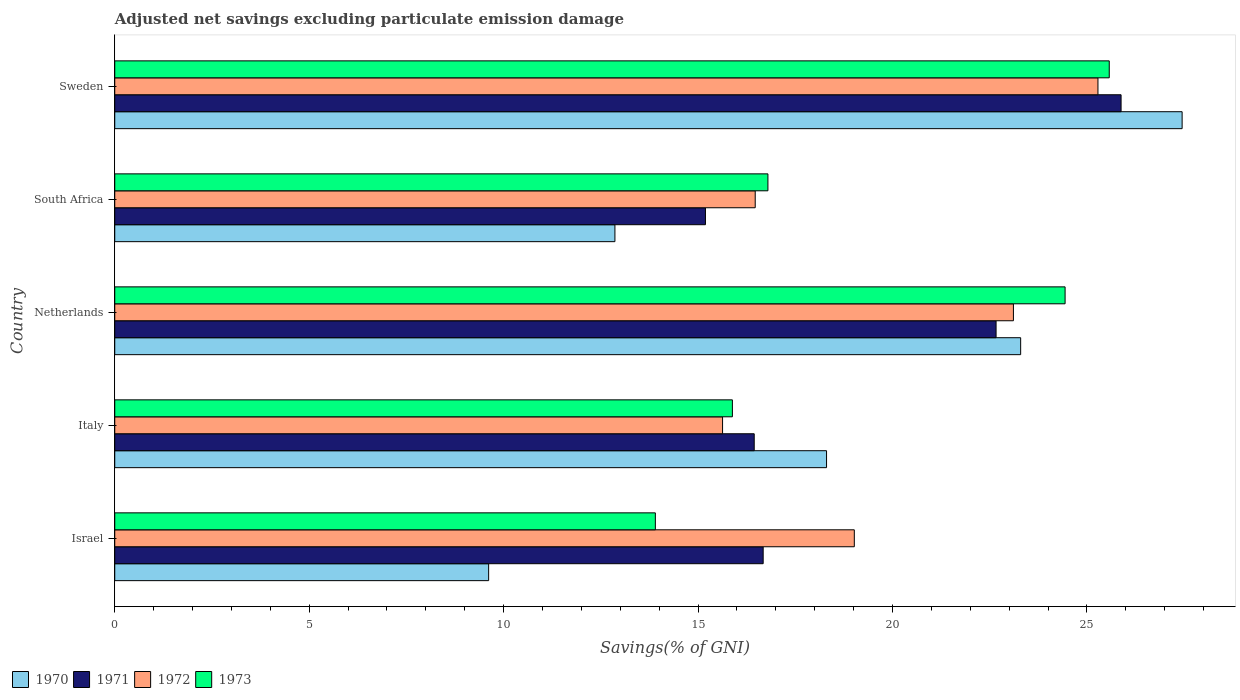How many different coloured bars are there?
Provide a short and direct response. 4. Are the number of bars on each tick of the Y-axis equal?
Give a very brief answer. Yes. What is the adjusted net savings in 1971 in Israel?
Offer a terse response. 16.67. Across all countries, what is the maximum adjusted net savings in 1971?
Your answer should be compact. 25.88. Across all countries, what is the minimum adjusted net savings in 1973?
Provide a short and direct response. 13.9. In which country was the adjusted net savings in 1972 maximum?
Provide a succinct answer. Sweden. In which country was the adjusted net savings in 1971 minimum?
Your answer should be very brief. South Africa. What is the total adjusted net savings in 1970 in the graph?
Offer a very short reply. 91.52. What is the difference between the adjusted net savings in 1972 in Italy and that in Netherlands?
Provide a short and direct response. -7.48. What is the difference between the adjusted net savings in 1972 in Italy and the adjusted net savings in 1973 in Israel?
Offer a terse response. 1.73. What is the average adjusted net savings in 1973 per country?
Your answer should be compact. 19.32. What is the difference between the adjusted net savings in 1970 and adjusted net savings in 1972 in Sweden?
Ensure brevity in your answer.  2.16. In how many countries, is the adjusted net savings in 1973 greater than 26 %?
Keep it short and to the point. 0. What is the ratio of the adjusted net savings in 1973 in Israel to that in Italy?
Ensure brevity in your answer.  0.88. Is the adjusted net savings in 1972 in South Africa less than that in Sweden?
Offer a terse response. Yes. What is the difference between the highest and the second highest adjusted net savings in 1971?
Offer a very short reply. 3.21. What is the difference between the highest and the lowest adjusted net savings in 1972?
Make the answer very short. 9.65. Is the sum of the adjusted net savings in 1972 in South Africa and Sweden greater than the maximum adjusted net savings in 1970 across all countries?
Keep it short and to the point. Yes. What does the 2nd bar from the top in Sweden represents?
Provide a short and direct response. 1972. Is it the case that in every country, the sum of the adjusted net savings in 1970 and adjusted net savings in 1973 is greater than the adjusted net savings in 1971?
Ensure brevity in your answer.  Yes. How many bars are there?
Offer a very short reply. 20. How many countries are there in the graph?
Keep it short and to the point. 5. What is the difference between two consecutive major ticks on the X-axis?
Offer a very short reply. 5. Does the graph contain any zero values?
Provide a short and direct response. No. Does the graph contain grids?
Provide a succinct answer. No. How many legend labels are there?
Provide a short and direct response. 4. How are the legend labels stacked?
Offer a very short reply. Horizontal. What is the title of the graph?
Offer a very short reply. Adjusted net savings excluding particulate emission damage. Does "2001" appear as one of the legend labels in the graph?
Provide a short and direct response. No. What is the label or title of the X-axis?
Your answer should be very brief. Savings(% of GNI). What is the label or title of the Y-axis?
Offer a very short reply. Country. What is the Savings(% of GNI) of 1970 in Israel?
Give a very brief answer. 9.61. What is the Savings(% of GNI) in 1971 in Israel?
Keep it short and to the point. 16.67. What is the Savings(% of GNI) in 1972 in Israel?
Offer a very short reply. 19.02. What is the Savings(% of GNI) in 1973 in Israel?
Offer a terse response. 13.9. What is the Savings(% of GNI) of 1970 in Italy?
Your response must be concise. 18.3. What is the Savings(% of GNI) in 1971 in Italy?
Your response must be concise. 16.44. What is the Savings(% of GNI) in 1972 in Italy?
Provide a short and direct response. 15.63. What is the Savings(% of GNI) in 1973 in Italy?
Offer a very short reply. 15.88. What is the Savings(% of GNI) in 1970 in Netherlands?
Offer a terse response. 23.3. What is the Savings(% of GNI) of 1971 in Netherlands?
Provide a succinct answer. 22.66. What is the Savings(% of GNI) of 1972 in Netherlands?
Provide a succinct answer. 23.11. What is the Savings(% of GNI) of 1973 in Netherlands?
Provide a short and direct response. 24.44. What is the Savings(% of GNI) in 1970 in South Africa?
Provide a succinct answer. 12.86. What is the Savings(% of GNI) of 1971 in South Africa?
Make the answer very short. 15.19. What is the Savings(% of GNI) in 1972 in South Africa?
Provide a short and direct response. 16.47. What is the Savings(% of GNI) of 1973 in South Africa?
Provide a succinct answer. 16.8. What is the Savings(% of GNI) of 1970 in Sweden?
Offer a very short reply. 27.45. What is the Savings(% of GNI) of 1971 in Sweden?
Provide a short and direct response. 25.88. What is the Savings(% of GNI) in 1972 in Sweden?
Your response must be concise. 25.28. What is the Savings(% of GNI) in 1973 in Sweden?
Offer a very short reply. 25.57. Across all countries, what is the maximum Savings(% of GNI) in 1970?
Your answer should be very brief. 27.45. Across all countries, what is the maximum Savings(% of GNI) in 1971?
Your answer should be very brief. 25.88. Across all countries, what is the maximum Savings(% of GNI) in 1972?
Ensure brevity in your answer.  25.28. Across all countries, what is the maximum Savings(% of GNI) in 1973?
Your response must be concise. 25.57. Across all countries, what is the minimum Savings(% of GNI) of 1970?
Your answer should be compact. 9.61. Across all countries, what is the minimum Savings(% of GNI) of 1971?
Give a very brief answer. 15.19. Across all countries, what is the minimum Savings(% of GNI) in 1972?
Make the answer very short. 15.63. Across all countries, what is the minimum Savings(% of GNI) in 1973?
Your response must be concise. 13.9. What is the total Savings(% of GNI) of 1970 in the graph?
Give a very brief answer. 91.52. What is the total Savings(% of GNI) of 1971 in the graph?
Keep it short and to the point. 96.85. What is the total Savings(% of GNI) in 1972 in the graph?
Make the answer very short. 99.51. What is the total Savings(% of GNI) of 1973 in the graph?
Provide a short and direct response. 96.59. What is the difference between the Savings(% of GNI) in 1970 in Israel and that in Italy?
Offer a very short reply. -8.69. What is the difference between the Savings(% of GNI) of 1971 in Israel and that in Italy?
Your response must be concise. 0.23. What is the difference between the Savings(% of GNI) in 1972 in Israel and that in Italy?
Give a very brief answer. 3.39. What is the difference between the Savings(% of GNI) of 1973 in Israel and that in Italy?
Provide a short and direct response. -1.98. What is the difference between the Savings(% of GNI) of 1970 in Israel and that in Netherlands?
Offer a terse response. -13.68. What is the difference between the Savings(% of GNI) in 1971 in Israel and that in Netherlands?
Provide a succinct answer. -5.99. What is the difference between the Savings(% of GNI) of 1972 in Israel and that in Netherlands?
Give a very brief answer. -4.09. What is the difference between the Savings(% of GNI) in 1973 in Israel and that in Netherlands?
Provide a succinct answer. -10.54. What is the difference between the Savings(% of GNI) of 1970 in Israel and that in South Africa?
Your answer should be very brief. -3.25. What is the difference between the Savings(% of GNI) in 1971 in Israel and that in South Africa?
Your answer should be compact. 1.48. What is the difference between the Savings(% of GNI) in 1972 in Israel and that in South Africa?
Provide a succinct answer. 2.55. What is the difference between the Savings(% of GNI) in 1973 in Israel and that in South Africa?
Offer a very short reply. -2.89. What is the difference between the Savings(% of GNI) in 1970 in Israel and that in Sweden?
Ensure brevity in your answer.  -17.83. What is the difference between the Savings(% of GNI) in 1971 in Israel and that in Sweden?
Offer a very short reply. -9.2. What is the difference between the Savings(% of GNI) of 1972 in Israel and that in Sweden?
Your answer should be compact. -6.27. What is the difference between the Savings(% of GNI) in 1973 in Israel and that in Sweden?
Provide a succinct answer. -11.67. What is the difference between the Savings(% of GNI) of 1970 in Italy and that in Netherlands?
Make the answer very short. -4.99. What is the difference between the Savings(% of GNI) of 1971 in Italy and that in Netherlands?
Your answer should be compact. -6.22. What is the difference between the Savings(% of GNI) in 1972 in Italy and that in Netherlands?
Your answer should be compact. -7.48. What is the difference between the Savings(% of GNI) of 1973 in Italy and that in Netherlands?
Provide a short and direct response. -8.56. What is the difference between the Savings(% of GNI) of 1970 in Italy and that in South Africa?
Your answer should be compact. 5.44. What is the difference between the Savings(% of GNI) in 1971 in Italy and that in South Africa?
Provide a succinct answer. 1.25. What is the difference between the Savings(% of GNI) of 1972 in Italy and that in South Africa?
Provide a short and direct response. -0.84. What is the difference between the Savings(% of GNI) of 1973 in Italy and that in South Africa?
Your answer should be compact. -0.91. What is the difference between the Savings(% of GNI) in 1970 in Italy and that in Sweden?
Offer a terse response. -9.14. What is the difference between the Savings(% of GNI) in 1971 in Italy and that in Sweden?
Your response must be concise. -9.43. What is the difference between the Savings(% of GNI) in 1972 in Italy and that in Sweden?
Ensure brevity in your answer.  -9.65. What is the difference between the Savings(% of GNI) in 1973 in Italy and that in Sweden?
Ensure brevity in your answer.  -9.69. What is the difference between the Savings(% of GNI) of 1970 in Netherlands and that in South Africa?
Offer a terse response. 10.43. What is the difference between the Savings(% of GNI) of 1971 in Netherlands and that in South Africa?
Give a very brief answer. 7.47. What is the difference between the Savings(% of GNI) of 1972 in Netherlands and that in South Africa?
Offer a terse response. 6.64. What is the difference between the Savings(% of GNI) in 1973 in Netherlands and that in South Africa?
Offer a terse response. 7.64. What is the difference between the Savings(% of GNI) in 1970 in Netherlands and that in Sweden?
Ensure brevity in your answer.  -4.15. What is the difference between the Savings(% of GNI) of 1971 in Netherlands and that in Sweden?
Make the answer very short. -3.21. What is the difference between the Savings(% of GNI) of 1972 in Netherlands and that in Sweden?
Your answer should be very brief. -2.17. What is the difference between the Savings(% of GNI) in 1973 in Netherlands and that in Sweden?
Give a very brief answer. -1.14. What is the difference between the Savings(% of GNI) in 1970 in South Africa and that in Sweden?
Your answer should be compact. -14.59. What is the difference between the Savings(% of GNI) of 1971 in South Africa and that in Sweden?
Give a very brief answer. -10.69. What is the difference between the Savings(% of GNI) in 1972 in South Africa and that in Sweden?
Keep it short and to the point. -8.81. What is the difference between the Savings(% of GNI) of 1973 in South Africa and that in Sweden?
Ensure brevity in your answer.  -8.78. What is the difference between the Savings(% of GNI) of 1970 in Israel and the Savings(% of GNI) of 1971 in Italy?
Keep it short and to the point. -6.83. What is the difference between the Savings(% of GNI) of 1970 in Israel and the Savings(% of GNI) of 1972 in Italy?
Make the answer very short. -6.02. What is the difference between the Savings(% of GNI) of 1970 in Israel and the Savings(% of GNI) of 1973 in Italy?
Offer a terse response. -6.27. What is the difference between the Savings(% of GNI) in 1971 in Israel and the Savings(% of GNI) in 1972 in Italy?
Your answer should be compact. 1.04. What is the difference between the Savings(% of GNI) of 1971 in Israel and the Savings(% of GNI) of 1973 in Italy?
Keep it short and to the point. 0.79. What is the difference between the Savings(% of GNI) of 1972 in Israel and the Savings(% of GNI) of 1973 in Italy?
Give a very brief answer. 3.14. What is the difference between the Savings(% of GNI) in 1970 in Israel and the Savings(% of GNI) in 1971 in Netherlands?
Your answer should be very brief. -13.05. What is the difference between the Savings(% of GNI) of 1970 in Israel and the Savings(% of GNI) of 1972 in Netherlands?
Your answer should be compact. -13.49. What is the difference between the Savings(% of GNI) in 1970 in Israel and the Savings(% of GNI) in 1973 in Netherlands?
Your response must be concise. -14.82. What is the difference between the Savings(% of GNI) in 1971 in Israel and the Savings(% of GNI) in 1972 in Netherlands?
Keep it short and to the point. -6.44. What is the difference between the Savings(% of GNI) in 1971 in Israel and the Savings(% of GNI) in 1973 in Netherlands?
Give a very brief answer. -7.76. What is the difference between the Savings(% of GNI) of 1972 in Israel and the Savings(% of GNI) of 1973 in Netherlands?
Give a very brief answer. -5.42. What is the difference between the Savings(% of GNI) in 1970 in Israel and the Savings(% of GNI) in 1971 in South Africa?
Your response must be concise. -5.58. What is the difference between the Savings(% of GNI) in 1970 in Israel and the Savings(% of GNI) in 1972 in South Africa?
Your answer should be compact. -6.86. What is the difference between the Savings(% of GNI) in 1970 in Israel and the Savings(% of GNI) in 1973 in South Africa?
Give a very brief answer. -7.18. What is the difference between the Savings(% of GNI) of 1971 in Israel and the Savings(% of GNI) of 1972 in South Africa?
Provide a short and direct response. 0.2. What is the difference between the Savings(% of GNI) of 1971 in Israel and the Savings(% of GNI) of 1973 in South Africa?
Offer a very short reply. -0.12. What is the difference between the Savings(% of GNI) of 1972 in Israel and the Savings(% of GNI) of 1973 in South Africa?
Offer a terse response. 2.22. What is the difference between the Savings(% of GNI) of 1970 in Israel and the Savings(% of GNI) of 1971 in Sweden?
Keep it short and to the point. -16.26. What is the difference between the Savings(% of GNI) in 1970 in Israel and the Savings(% of GNI) in 1972 in Sweden?
Ensure brevity in your answer.  -15.67. What is the difference between the Savings(% of GNI) in 1970 in Israel and the Savings(% of GNI) in 1973 in Sweden?
Provide a succinct answer. -15.96. What is the difference between the Savings(% of GNI) of 1971 in Israel and the Savings(% of GNI) of 1972 in Sweden?
Your answer should be compact. -8.61. What is the difference between the Savings(% of GNI) in 1971 in Israel and the Savings(% of GNI) in 1973 in Sweden?
Your response must be concise. -8.9. What is the difference between the Savings(% of GNI) of 1972 in Israel and the Savings(% of GNI) of 1973 in Sweden?
Your answer should be very brief. -6.56. What is the difference between the Savings(% of GNI) in 1970 in Italy and the Savings(% of GNI) in 1971 in Netherlands?
Give a very brief answer. -4.36. What is the difference between the Savings(% of GNI) in 1970 in Italy and the Savings(% of GNI) in 1972 in Netherlands?
Your response must be concise. -4.81. What is the difference between the Savings(% of GNI) of 1970 in Italy and the Savings(% of GNI) of 1973 in Netherlands?
Offer a terse response. -6.13. What is the difference between the Savings(% of GNI) of 1971 in Italy and the Savings(% of GNI) of 1972 in Netherlands?
Give a very brief answer. -6.67. What is the difference between the Savings(% of GNI) in 1971 in Italy and the Savings(% of GNI) in 1973 in Netherlands?
Keep it short and to the point. -7.99. What is the difference between the Savings(% of GNI) of 1972 in Italy and the Savings(% of GNI) of 1973 in Netherlands?
Keep it short and to the point. -8.81. What is the difference between the Savings(% of GNI) of 1970 in Italy and the Savings(% of GNI) of 1971 in South Africa?
Provide a succinct answer. 3.11. What is the difference between the Savings(% of GNI) in 1970 in Italy and the Savings(% of GNI) in 1972 in South Africa?
Your answer should be very brief. 1.83. What is the difference between the Savings(% of GNI) in 1970 in Italy and the Savings(% of GNI) in 1973 in South Africa?
Your answer should be very brief. 1.51. What is the difference between the Savings(% of GNI) of 1971 in Italy and the Savings(% of GNI) of 1972 in South Africa?
Keep it short and to the point. -0.03. What is the difference between the Savings(% of GNI) in 1971 in Italy and the Savings(% of GNI) in 1973 in South Africa?
Provide a succinct answer. -0.35. What is the difference between the Savings(% of GNI) of 1972 in Italy and the Savings(% of GNI) of 1973 in South Africa?
Ensure brevity in your answer.  -1.17. What is the difference between the Savings(% of GNI) of 1970 in Italy and the Savings(% of GNI) of 1971 in Sweden?
Your answer should be compact. -7.57. What is the difference between the Savings(% of GNI) of 1970 in Italy and the Savings(% of GNI) of 1972 in Sweden?
Provide a short and direct response. -6.98. What is the difference between the Savings(% of GNI) of 1970 in Italy and the Savings(% of GNI) of 1973 in Sweden?
Your answer should be very brief. -7.27. What is the difference between the Savings(% of GNI) in 1971 in Italy and the Savings(% of GNI) in 1972 in Sweden?
Offer a terse response. -8.84. What is the difference between the Savings(% of GNI) of 1971 in Italy and the Savings(% of GNI) of 1973 in Sweden?
Your answer should be compact. -9.13. What is the difference between the Savings(% of GNI) of 1972 in Italy and the Savings(% of GNI) of 1973 in Sweden?
Your answer should be compact. -9.94. What is the difference between the Savings(% of GNI) in 1970 in Netherlands and the Savings(% of GNI) in 1971 in South Africa?
Your response must be concise. 8.11. What is the difference between the Savings(% of GNI) in 1970 in Netherlands and the Savings(% of GNI) in 1972 in South Africa?
Keep it short and to the point. 6.83. What is the difference between the Savings(% of GNI) in 1970 in Netherlands and the Savings(% of GNI) in 1973 in South Africa?
Offer a terse response. 6.5. What is the difference between the Savings(% of GNI) of 1971 in Netherlands and the Savings(% of GNI) of 1972 in South Africa?
Offer a very short reply. 6.19. What is the difference between the Savings(% of GNI) in 1971 in Netherlands and the Savings(% of GNI) in 1973 in South Africa?
Your answer should be very brief. 5.87. What is the difference between the Savings(% of GNI) of 1972 in Netherlands and the Savings(% of GNI) of 1973 in South Africa?
Offer a very short reply. 6.31. What is the difference between the Savings(% of GNI) in 1970 in Netherlands and the Savings(% of GNI) in 1971 in Sweden?
Offer a terse response. -2.58. What is the difference between the Savings(% of GNI) of 1970 in Netherlands and the Savings(% of GNI) of 1972 in Sweden?
Your answer should be compact. -1.99. What is the difference between the Savings(% of GNI) of 1970 in Netherlands and the Savings(% of GNI) of 1973 in Sweden?
Your answer should be very brief. -2.28. What is the difference between the Savings(% of GNI) of 1971 in Netherlands and the Savings(% of GNI) of 1972 in Sweden?
Give a very brief answer. -2.62. What is the difference between the Savings(% of GNI) in 1971 in Netherlands and the Savings(% of GNI) in 1973 in Sweden?
Provide a succinct answer. -2.91. What is the difference between the Savings(% of GNI) of 1972 in Netherlands and the Savings(% of GNI) of 1973 in Sweden?
Give a very brief answer. -2.46. What is the difference between the Savings(% of GNI) of 1970 in South Africa and the Savings(% of GNI) of 1971 in Sweden?
Make the answer very short. -13.02. What is the difference between the Savings(% of GNI) of 1970 in South Africa and the Savings(% of GNI) of 1972 in Sweden?
Provide a succinct answer. -12.42. What is the difference between the Savings(% of GNI) in 1970 in South Africa and the Savings(% of GNI) in 1973 in Sweden?
Your answer should be compact. -12.71. What is the difference between the Savings(% of GNI) of 1971 in South Africa and the Savings(% of GNI) of 1972 in Sweden?
Your answer should be compact. -10.09. What is the difference between the Savings(% of GNI) in 1971 in South Africa and the Savings(% of GNI) in 1973 in Sweden?
Offer a very short reply. -10.38. What is the difference between the Savings(% of GNI) in 1972 in South Africa and the Savings(% of GNI) in 1973 in Sweden?
Provide a short and direct response. -9.1. What is the average Savings(% of GNI) in 1970 per country?
Your answer should be compact. 18.3. What is the average Savings(% of GNI) of 1971 per country?
Keep it short and to the point. 19.37. What is the average Savings(% of GNI) in 1972 per country?
Keep it short and to the point. 19.9. What is the average Savings(% of GNI) in 1973 per country?
Make the answer very short. 19.32. What is the difference between the Savings(% of GNI) of 1970 and Savings(% of GNI) of 1971 in Israel?
Offer a very short reply. -7.06. What is the difference between the Savings(% of GNI) in 1970 and Savings(% of GNI) in 1972 in Israel?
Your answer should be compact. -9.4. What is the difference between the Savings(% of GNI) of 1970 and Savings(% of GNI) of 1973 in Israel?
Give a very brief answer. -4.29. What is the difference between the Savings(% of GNI) of 1971 and Savings(% of GNI) of 1972 in Israel?
Your answer should be very brief. -2.34. What is the difference between the Savings(% of GNI) in 1971 and Savings(% of GNI) in 1973 in Israel?
Provide a succinct answer. 2.77. What is the difference between the Savings(% of GNI) of 1972 and Savings(% of GNI) of 1973 in Israel?
Your response must be concise. 5.12. What is the difference between the Savings(% of GNI) in 1970 and Savings(% of GNI) in 1971 in Italy?
Provide a short and direct response. 1.86. What is the difference between the Savings(% of GNI) in 1970 and Savings(% of GNI) in 1972 in Italy?
Keep it short and to the point. 2.67. What is the difference between the Savings(% of GNI) in 1970 and Savings(% of GNI) in 1973 in Italy?
Provide a short and direct response. 2.42. What is the difference between the Savings(% of GNI) in 1971 and Savings(% of GNI) in 1972 in Italy?
Make the answer very short. 0.81. What is the difference between the Savings(% of GNI) of 1971 and Savings(% of GNI) of 1973 in Italy?
Offer a very short reply. 0.56. What is the difference between the Savings(% of GNI) in 1972 and Savings(% of GNI) in 1973 in Italy?
Provide a succinct answer. -0.25. What is the difference between the Savings(% of GNI) in 1970 and Savings(% of GNI) in 1971 in Netherlands?
Give a very brief answer. 0.63. What is the difference between the Savings(% of GNI) in 1970 and Savings(% of GNI) in 1972 in Netherlands?
Your response must be concise. 0.19. What is the difference between the Savings(% of GNI) of 1970 and Savings(% of GNI) of 1973 in Netherlands?
Provide a succinct answer. -1.14. What is the difference between the Savings(% of GNI) in 1971 and Savings(% of GNI) in 1972 in Netherlands?
Provide a short and direct response. -0.45. What is the difference between the Savings(% of GNI) in 1971 and Savings(% of GNI) in 1973 in Netherlands?
Give a very brief answer. -1.77. What is the difference between the Savings(% of GNI) of 1972 and Savings(% of GNI) of 1973 in Netherlands?
Your response must be concise. -1.33. What is the difference between the Savings(% of GNI) in 1970 and Savings(% of GNI) in 1971 in South Africa?
Offer a very short reply. -2.33. What is the difference between the Savings(% of GNI) in 1970 and Savings(% of GNI) in 1972 in South Africa?
Your response must be concise. -3.61. What is the difference between the Savings(% of GNI) in 1970 and Savings(% of GNI) in 1973 in South Africa?
Give a very brief answer. -3.93. What is the difference between the Savings(% of GNI) in 1971 and Savings(% of GNI) in 1972 in South Africa?
Keep it short and to the point. -1.28. What is the difference between the Savings(% of GNI) in 1971 and Savings(% of GNI) in 1973 in South Africa?
Provide a short and direct response. -1.61. What is the difference between the Savings(% of GNI) in 1972 and Savings(% of GNI) in 1973 in South Africa?
Your answer should be compact. -0.33. What is the difference between the Savings(% of GNI) in 1970 and Savings(% of GNI) in 1971 in Sweden?
Your response must be concise. 1.57. What is the difference between the Savings(% of GNI) in 1970 and Savings(% of GNI) in 1972 in Sweden?
Your answer should be compact. 2.16. What is the difference between the Savings(% of GNI) in 1970 and Savings(% of GNI) in 1973 in Sweden?
Your answer should be compact. 1.87. What is the difference between the Savings(% of GNI) in 1971 and Savings(% of GNI) in 1972 in Sweden?
Offer a terse response. 0.59. What is the difference between the Savings(% of GNI) of 1971 and Savings(% of GNI) of 1973 in Sweden?
Ensure brevity in your answer.  0.3. What is the difference between the Savings(% of GNI) in 1972 and Savings(% of GNI) in 1973 in Sweden?
Give a very brief answer. -0.29. What is the ratio of the Savings(% of GNI) of 1970 in Israel to that in Italy?
Offer a very short reply. 0.53. What is the ratio of the Savings(% of GNI) of 1971 in Israel to that in Italy?
Provide a succinct answer. 1.01. What is the ratio of the Savings(% of GNI) in 1972 in Israel to that in Italy?
Offer a terse response. 1.22. What is the ratio of the Savings(% of GNI) of 1973 in Israel to that in Italy?
Ensure brevity in your answer.  0.88. What is the ratio of the Savings(% of GNI) in 1970 in Israel to that in Netherlands?
Your answer should be very brief. 0.41. What is the ratio of the Savings(% of GNI) in 1971 in Israel to that in Netherlands?
Your answer should be compact. 0.74. What is the ratio of the Savings(% of GNI) of 1972 in Israel to that in Netherlands?
Ensure brevity in your answer.  0.82. What is the ratio of the Savings(% of GNI) of 1973 in Israel to that in Netherlands?
Your answer should be very brief. 0.57. What is the ratio of the Savings(% of GNI) of 1970 in Israel to that in South Africa?
Keep it short and to the point. 0.75. What is the ratio of the Savings(% of GNI) of 1971 in Israel to that in South Africa?
Provide a succinct answer. 1.1. What is the ratio of the Savings(% of GNI) of 1972 in Israel to that in South Africa?
Your response must be concise. 1.15. What is the ratio of the Savings(% of GNI) in 1973 in Israel to that in South Africa?
Ensure brevity in your answer.  0.83. What is the ratio of the Savings(% of GNI) of 1970 in Israel to that in Sweden?
Offer a very short reply. 0.35. What is the ratio of the Savings(% of GNI) of 1971 in Israel to that in Sweden?
Your answer should be compact. 0.64. What is the ratio of the Savings(% of GNI) in 1972 in Israel to that in Sweden?
Offer a very short reply. 0.75. What is the ratio of the Savings(% of GNI) in 1973 in Israel to that in Sweden?
Your answer should be very brief. 0.54. What is the ratio of the Savings(% of GNI) of 1970 in Italy to that in Netherlands?
Your answer should be very brief. 0.79. What is the ratio of the Savings(% of GNI) in 1971 in Italy to that in Netherlands?
Provide a short and direct response. 0.73. What is the ratio of the Savings(% of GNI) in 1972 in Italy to that in Netherlands?
Your answer should be compact. 0.68. What is the ratio of the Savings(% of GNI) in 1973 in Italy to that in Netherlands?
Provide a short and direct response. 0.65. What is the ratio of the Savings(% of GNI) of 1970 in Italy to that in South Africa?
Provide a short and direct response. 1.42. What is the ratio of the Savings(% of GNI) of 1971 in Italy to that in South Africa?
Give a very brief answer. 1.08. What is the ratio of the Savings(% of GNI) of 1972 in Italy to that in South Africa?
Make the answer very short. 0.95. What is the ratio of the Savings(% of GNI) in 1973 in Italy to that in South Africa?
Offer a terse response. 0.95. What is the ratio of the Savings(% of GNI) of 1970 in Italy to that in Sweden?
Ensure brevity in your answer.  0.67. What is the ratio of the Savings(% of GNI) in 1971 in Italy to that in Sweden?
Give a very brief answer. 0.64. What is the ratio of the Savings(% of GNI) in 1972 in Italy to that in Sweden?
Keep it short and to the point. 0.62. What is the ratio of the Savings(% of GNI) in 1973 in Italy to that in Sweden?
Your answer should be very brief. 0.62. What is the ratio of the Savings(% of GNI) of 1970 in Netherlands to that in South Africa?
Offer a very short reply. 1.81. What is the ratio of the Savings(% of GNI) of 1971 in Netherlands to that in South Africa?
Provide a succinct answer. 1.49. What is the ratio of the Savings(% of GNI) in 1972 in Netherlands to that in South Africa?
Provide a succinct answer. 1.4. What is the ratio of the Savings(% of GNI) in 1973 in Netherlands to that in South Africa?
Provide a succinct answer. 1.46. What is the ratio of the Savings(% of GNI) in 1970 in Netherlands to that in Sweden?
Provide a short and direct response. 0.85. What is the ratio of the Savings(% of GNI) of 1971 in Netherlands to that in Sweden?
Make the answer very short. 0.88. What is the ratio of the Savings(% of GNI) of 1972 in Netherlands to that in Sweden?
Provide a short and direct response. 0.91. What is the ratio of the Savings(% of GNI) in 1973 in Netherlands to that in Sweden?
Provide a short and direct response. 0.96. What is the ratio of the Savings(% of GNI) in 1970 in South Africa to that in Sweden?
Offer a very short reply. 0.47. What is the ratio of the Savings(% of GNI) in 1971 in South Africa to that in Sweden?
Your answer should be compact. 0.59. What is the ratio of the Savings(% of GNI) of 1972 in South Africa to that in Sweden?
Your response must be concise. 0.65. What is the ratio of the Savings(% of GNI) of 1973 in South Africa to that in Sweden?
Ensure brevity in your answer.  0.66. What is the difference between the highest and the second highest Savings(% of GNI) in 1970?
Give a very brief answer. 4.15. What is the difference between the highest and the second highest Savings(% of GNI) in 1971?
Provide a succinct answer. 3.21. What is the difference between the highest and the second highest Savings(% of GNI) in 1972?
Give a very brief answer. 2.17. What is the difference between the highest and the second highest Savings(% of GNI) of 1973?
Your answer should be very brief. 1.14. What is the difference between the highest and the lowest Savings(% of GNI) of 1970?
Make the answer very short. 17.83. What is the difference between the highest and the lowest Savings(% of GNI) of 1971?
Your answer should be very brief. 10.69. What is the difference between the highest and the lowest Savings(% of GNI) in 1972?
Give a very brief answer. 9.65. What is the difference between the highest and the lowest Savings(% of GNI) of 1973?
Ensure brevity in your answer.  11.67. 